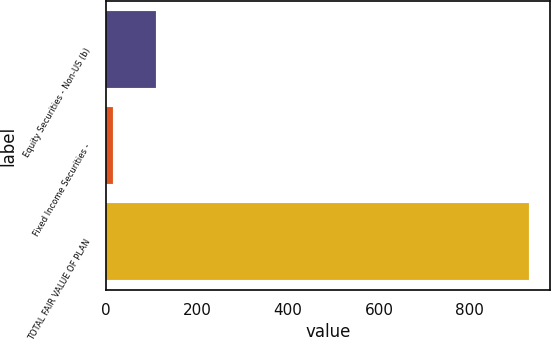Convert chart. <chart><loc_0><loc_0><loc_500><loc_500><bar_chart><fcel>Equity Securities - Non-US (b)<fcel>Fixed Income Securities -<fcel>TOTAL FAIR VALUE OF PLAN<nl><fcel>110<fcel>15<fcel>930<nl></chart> 